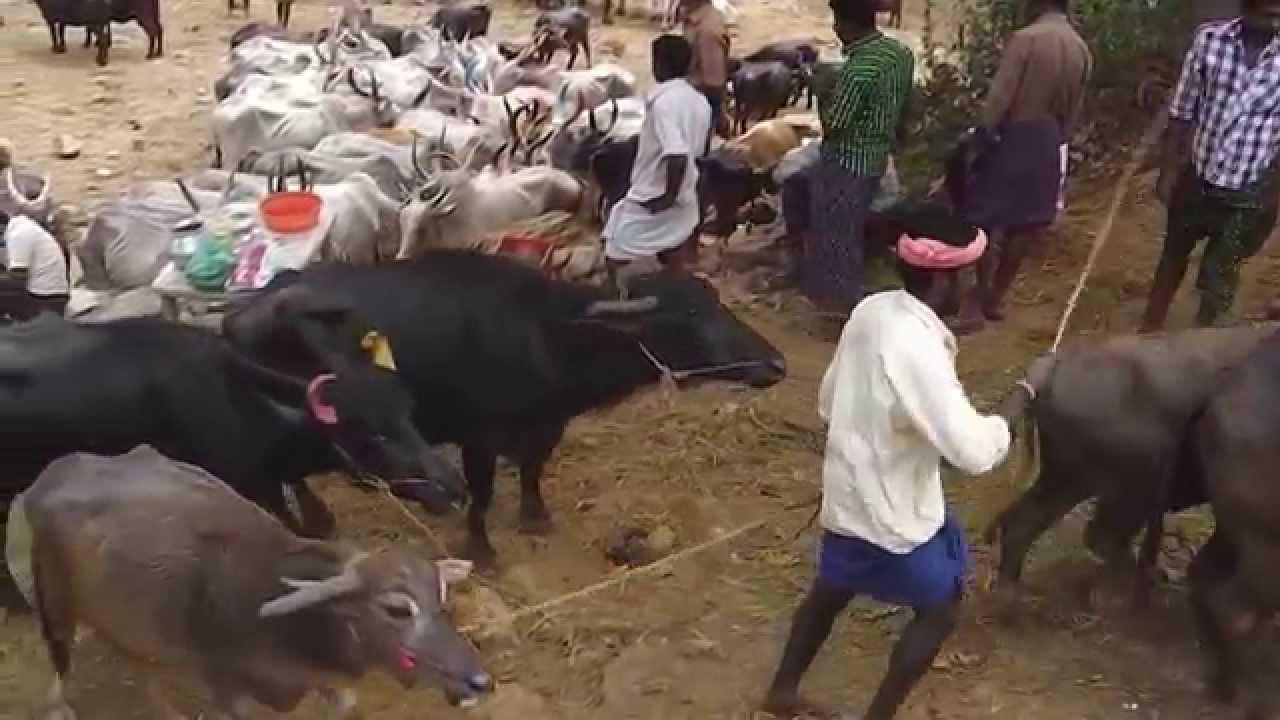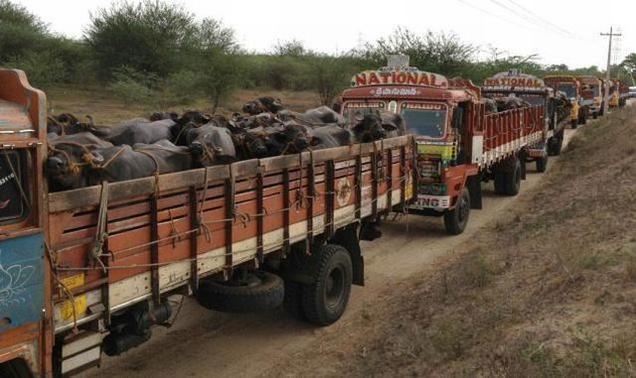The first image is the image on the left, the second image is the image on the right. Considering the images on both sides, is "Two hunters pose with a weapon behind a downed water buffalo in the left image." valid? Answer yes or no. No. The first image is the image on the left, the second image is the image on the right. For the images shown, is this caption "In one of the images, two men can be seen posing next to a deceased water buffalo." true? Answer yes or no. No. 